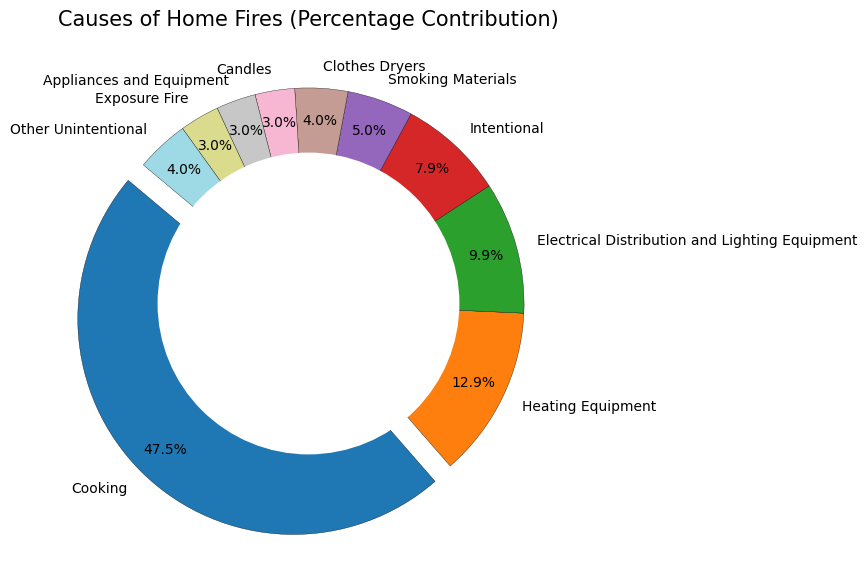What is the most common cause of home fires? The largest segment of the pie chart is exploded outward for emphasis, indicating that 'Cooking' is the most common cause.
Answer: Cooking What is the combined percentage contribution of 'Heating Equipment' and 'Electrical Distribution and Lighting Equipment'? 'Heating Equipment' contributes 13%, and 'Electrical Distribution and Lighting Equipment' contributes 10%. Adding these percentages: 13% + 10% = 23%.
Answer: 23% Which cause of home fires has the smallest contribution? The smallest segment in the pie chart is labeled as 'Candles', indicating that it has the smallest contribution.
Answer: Candles What is the difference in percentage contribution between 'Cooking' and 'Heating Equipment'? 'Cooking’ contributes 48% and 'Heating Equipment’ contributes 13%. The difference is: 48% - 13% = 35%.
Answer: 35% Is the percentage contribution of 'Smoking Materials' higher or lower than 'Clothes Dryers'? 'Smoking Materials' has a percentage contribution of 5%, while 'Clothes Dryers' has 4%. Since 5% is greater than 4%, 'Smoking Materials' is higher.
Answer: Higher What colors are used to represent 'Cooking' and 'Electrical Distribution and Lighting Equipment'? 'Cooking' is represented by a distinct and potentially contrasting color due to its separation from the other slices, while each segment has a unique color shade from the tab20 colormap range. By visually inspecting the pie chart, you can identify these colors.
Answer: Varies (context-specific) What is the total percentage contribution of all causes that individually contribute less than 5%? Causes under 5% are 'Smoking Materials', 'Clothes Dryers', 'Candles', 'Appliances and Equipment', and 'Exposure Fire', each contributing 5%, 4%, 3%, 3%, and 3%, respectively. Adding these percentages: 5% + 4% + 3% + 3% + 3% = 18%.
Answer: 18% What is the combined contribution of 'Intentional', 'Smoking Materials', and 'Other Unintentional'? 'Intentional' contributes 8%, 'Smoking Materials' contributes 5%, and 'Other Unintentional' contributes 4%. Adding these: 8% + 5% + 4% = 17%.
Answer: 17% How does the percentage of 'Heating Equipment' compare to the sum of 'Candles' and 'Appliances and Equipment'? 'Heating Equipment' contributes 13%. 'Candles' and 'Appliances and Equipment' contribute 3% each. Summing these: 3% + 3% = 6%. Since 13% > 6%, 'Heating Equipment' is higher.
Answer: Higher 